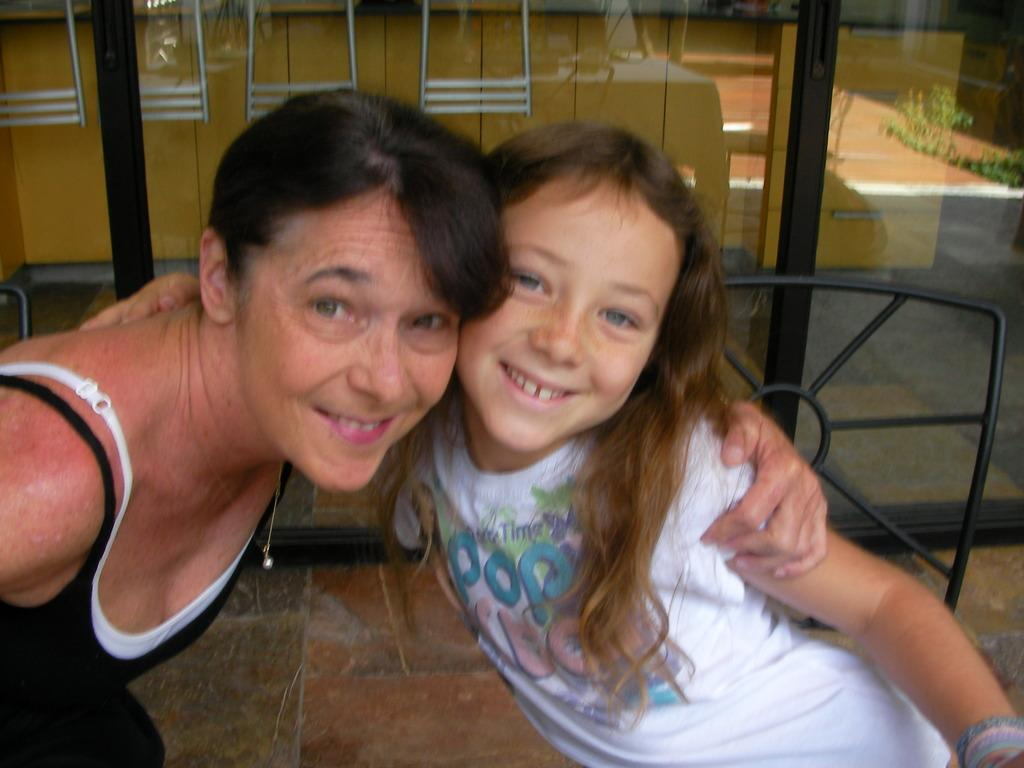Who is present in the image? There is a lady and a girl in the image. What are the expressions of the lady and the girl? Both the lady and the girl are smiling in the image. What can be seen in the background of the image? There is a glass door in the background of the image. What type of fog can be seen in the image? There is no fog present in the image; it features a lady and a girl smiling, along with a glass door in the background. What industry is depicted in the image? The image does not depict any specific industry; it is a simple scene of a lady and a girl smiling. 